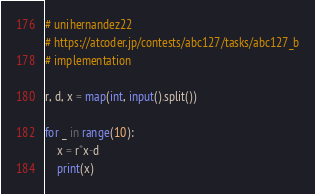Convert code to text. <code><loc_0><loc_0><loc_500><loc_500><_Python_># unihernandez22
# https://atcoder.jp/contests/abc127/tasks/abc127_b
# implementation

r, d, x = map(int, input().split())

for _ in range(10):
    x = r*x-d
    print(x)</code> 